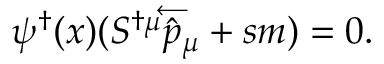Convert formula to latex. <formula><loc_0><loc_0><loc_500><loc_500>\psi ^ { \dagger } ( x ) ( S ^ { \dagger \mu } \overleftarrow { { \hat { p } } _ { \mu } } + s m ) = 0 .</formula> 